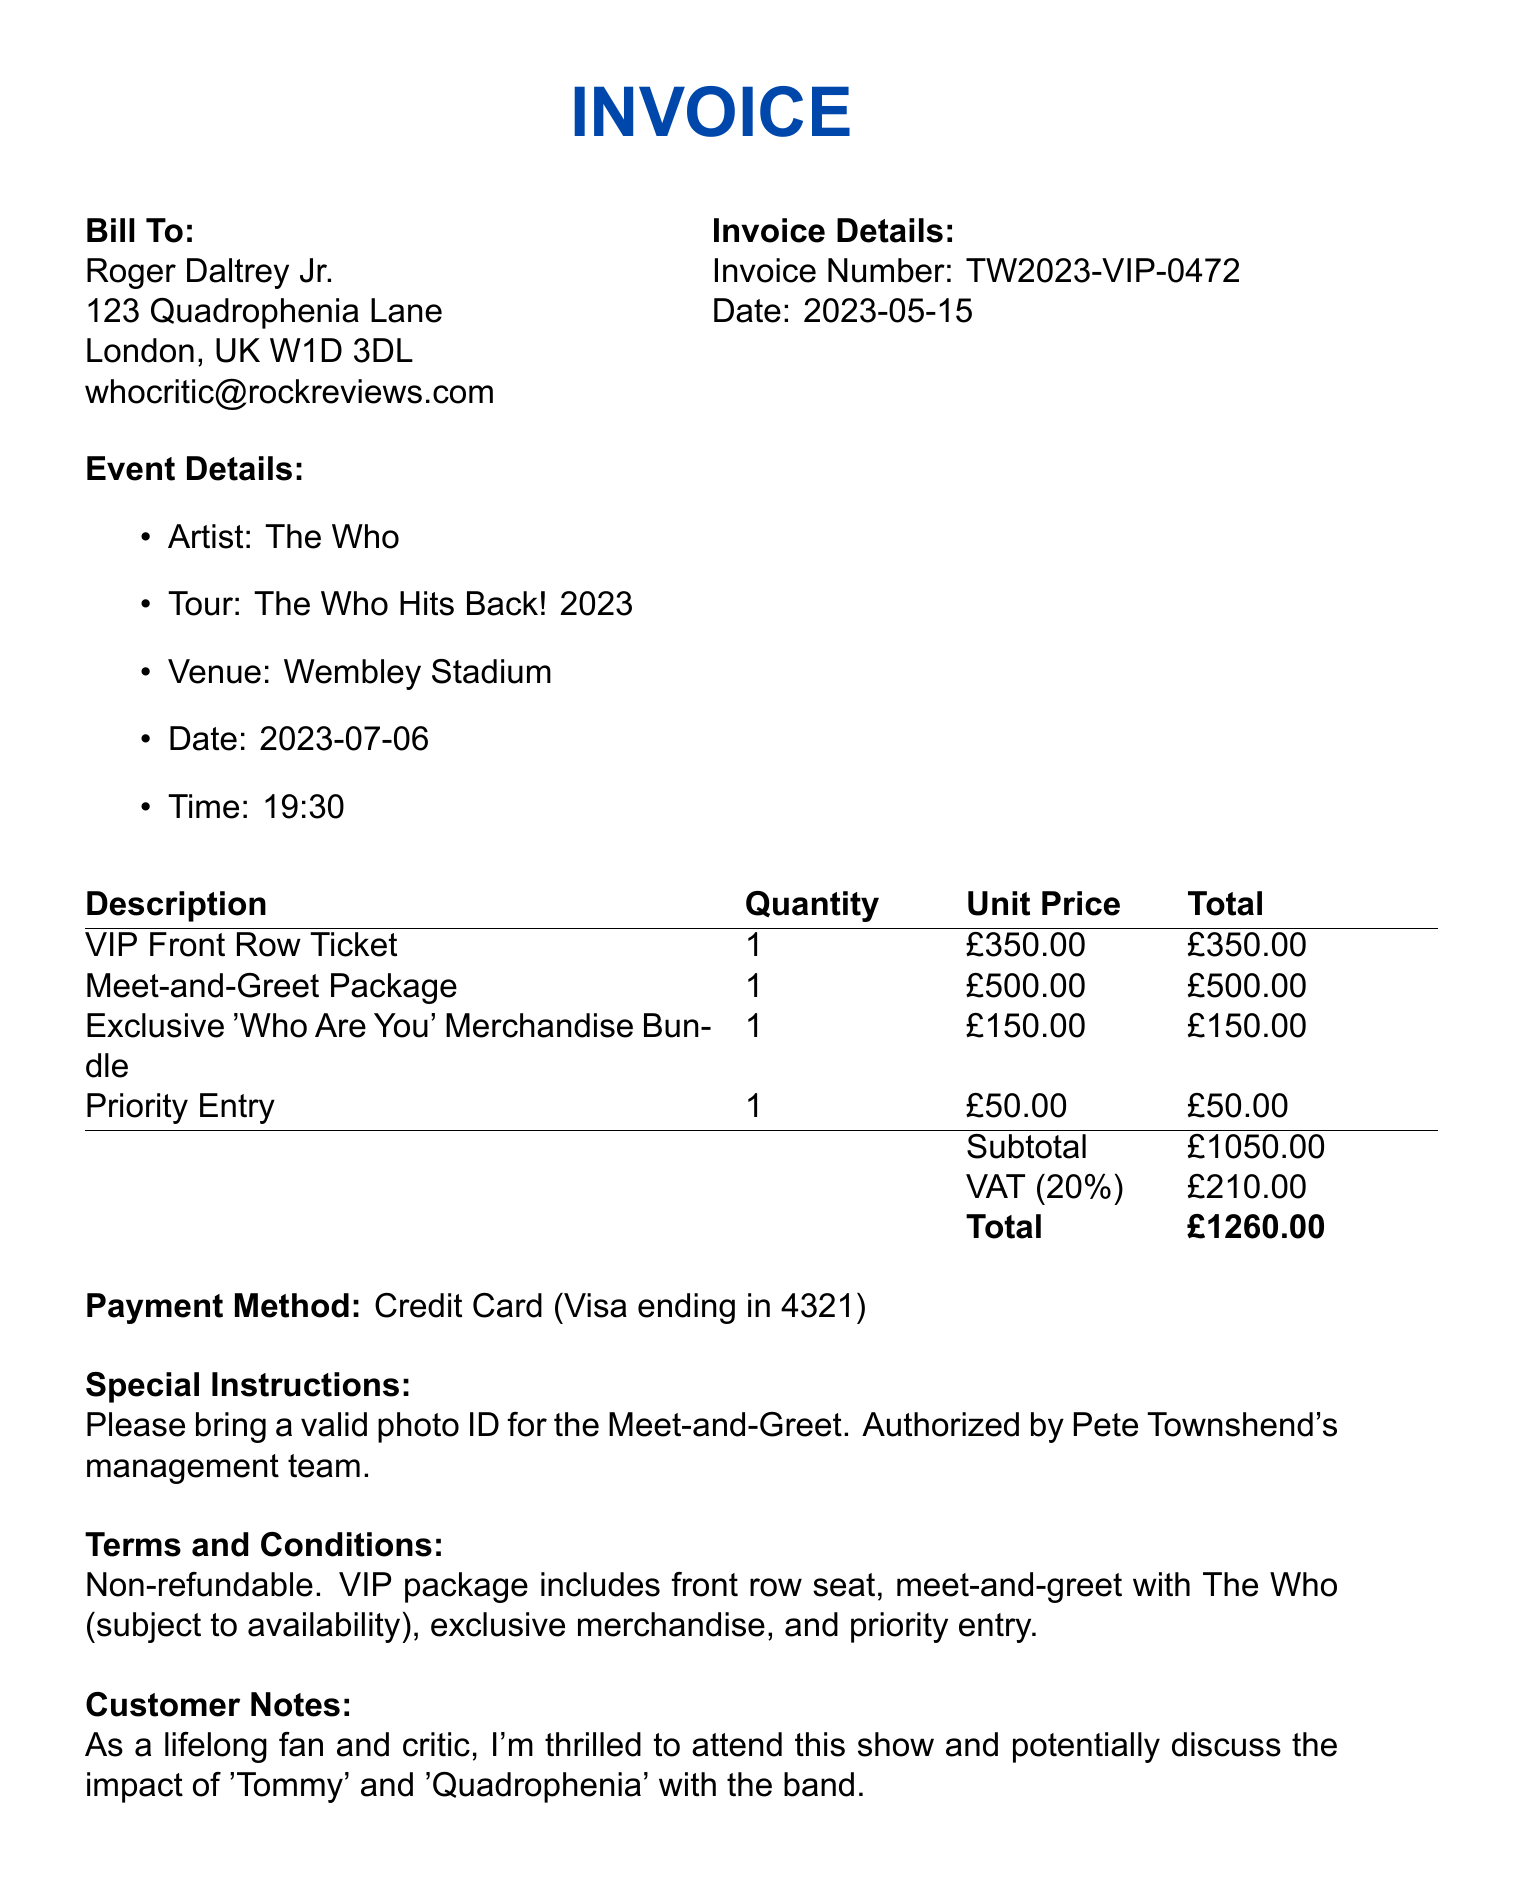What is the invoice number? The invoice number is specifically listed in the document as a unique identifier for this transaction.
Answer: TW2023-VIP-0472 What is the total amount due? The total amount is the final amount that needs to be paid, as calculated from the subtotal plus VAT.
Answer: £1260.00 What date is the concert scheduled for? The concert date is explicitly mentioned in the event details section of the document.
Answer: 2023-07-06 Who is the promoter for the concert? The promoter’s name is provided in the contact information section of the document.
Answer: Live Nation UK What merchandise is included in the order? This question requires looking at multiple items listed in the invoice to find merchandise included in the purchase.
Answer: Exclusive 'Who Are You' Merchandise Bundle How much is the VAT charged? The VAT amount is separately listed in the document, indicating the tax applied to the subtotal.
Answer: £210.00 What is required for the Meet-and-Greet? This information is found in the special instructions section, detailing what attendees must bring.
Answer: A valid photo ID What does the VIP package include? The terms and conditions describe what benefits are included with the VIP package, requiring synthesis of multiple pieces of information.
Answer: Front row seat, meet-and-greet with The Who, exclusive merchandise, and priority entry What payment method was used? The method of payment is noted in the document, specifying how the transaction was completed.
Answer: Credit Card (Visa ending in 4321) 